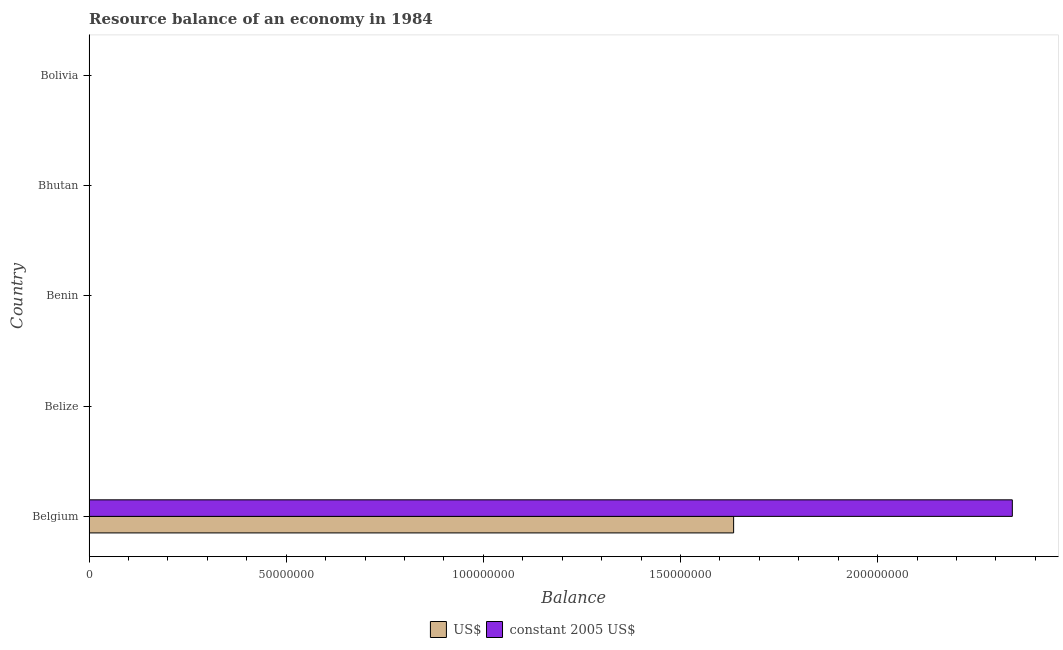Are the number of bars on each tick of the Y-axis equal?
Provide a short and direct response. No. How many bars are there on the 5th tick from the top?
Provide a short and direct response. 2. What is the label of the 3rd group of bars from the top?
Provide a succinct answer. Benin. In how many cases, is the number of bars for a given country not equal to the number of legend labels?
Offer a very short reply. 4. What is the resource balance in us$ in Belgium?
Provide a succinct answer. 1.63e+08. Across all countries, what is the maximum resource balance in us$?
Ensure brevity in your answer.  1.63e+08. In which country was the resource balance in constant us$ maximum?
Offer a terse response. Belgium. What is the total resource balance in constant us$ in the graph?
Ensure brevity in your answer.  2.34e+08. What is the difference between the resource balance in us$ in Benin and the resource balance in constant us$ in Belgium?
Keep it short and to the point. -2.34e+08. What is the average resource balance in us$ per country?
Give a very brief answer. 3.27e+07. What is the difference between the resource balance in us$ and resource balance in constant us$ in Belgium?
Your response must be concise. -7.07e+07. In how many countries, is the resource balance in us$ greater than 100000000 units?
Provide a short and direct response. 1. What is the difference between the highest and the lowest resource balance in us$?
Your answer should be very brief. 1.63e+08. How many bars are there?
Provide a succinct answer. 2. How many countries are there in the graph?
Make the answer very short. 5. Are the values on the major ticks of X-axis written in scientific E-notation?
Ensure brevity in your answer.  No. Does the graph contain any zero values?
Your response must be concise. Yes. How many legend labels are there?
Ensure brevity in your answer.  2. What is the title of the graph?
Your response must be concise. Resource balance of an economy in 1984. Does "Register a business" appear as one of the legend labels in the graph?
Keep it short and to the point. No. What is the label or title of the X-axis?
Offer a terse response. Balance. What is the Balance of US$ in Belgium?
Your answer should be very brief. 1.63e+08. What is the Balance of constant 2005 US$ in Belgium?
Your answer should be compact. 2.34e+08. What is the Balance of US$ in Belize?
Provide a short and direct response. 0. What is the Balance of constant 2005 US$ in Belize?
Offer a terse response. 0. What is the Balance of US$ in Bhutan?
Keep it short and to the point. 0. What is the Balance of US$ in Bolivia?
Your response must be concise. 0. Across all countries, what is the maximum Balance in US$?
Offer a terse response. 1.63e+08. Across all countries, what is the maximum Balance of constant 2005 US$?
Offer a terse response. 2.34e+08. Across all countries, what is the minimum Balance in US$?
Offer a terse response. 0. Across all countries, what is the minimum Balance of constant 2005 US$?
Keep it short and to the point. 0. What is the total Balance in US$ in the graph?
Offer a terse response. 1.63e+08. What is the total Balance in constant 2005 US$ in the graph?
Ensure brevity in your answer.  2.34e+08. What is the average Balance of US$ per country?
Give a very brief answer. 3.27e+07. What is the average Balance of constant 2005 US$ per country?
Offer a very short reply. 4.68e+07. What is the difference between the Balance in US$ and Balance in constant 2005 US$ in Belgium?
Provide a short and direct response. -7.07e+07. What is the difference between the highest and the lowest Balance in US$?
Keep it short and to the point. 1.63e+08. What is the difference between the highest and the lowest Balance in constant 2005 US$?
Your response must be concise. 2.34e+08. 